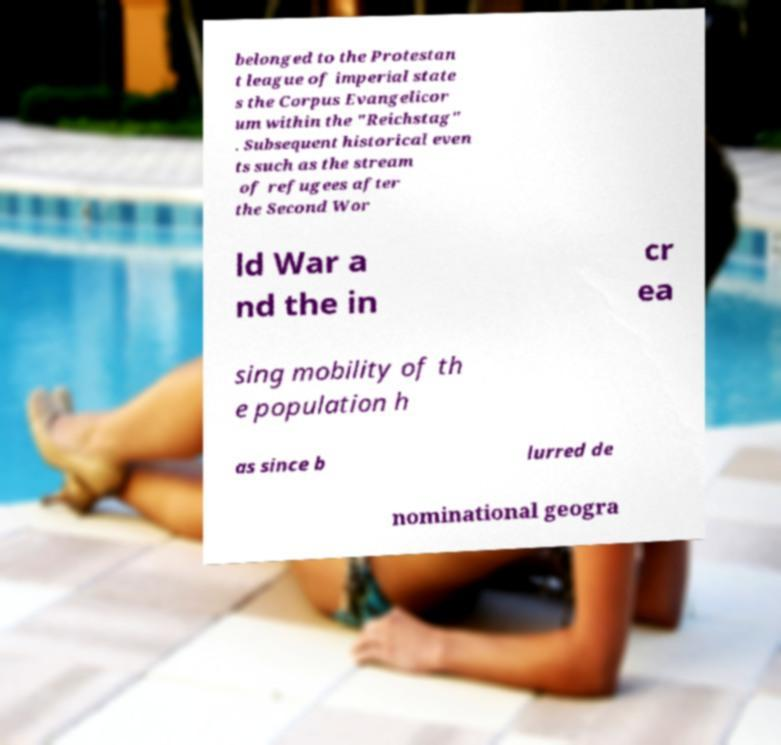There's text embedded in this image that I need extracted. Can you transcribe it verbatim? belonged to the Protestan t league of imperial state s the Corpus Evangelicor um within the "Reichstag" . Subsequent historical even ts such as the stream of refugees after the Second Wor ld War a nd the in cr ea sing mobility of th e population h as since b lurred de nominational geogra 